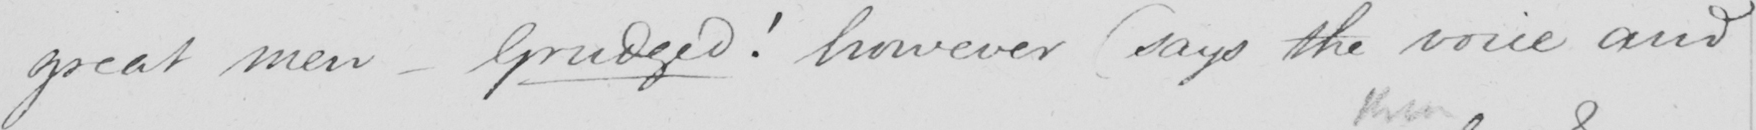Can you tell me what this handwritten text says? great men  _  Grudged !  however  ( says the voice and 